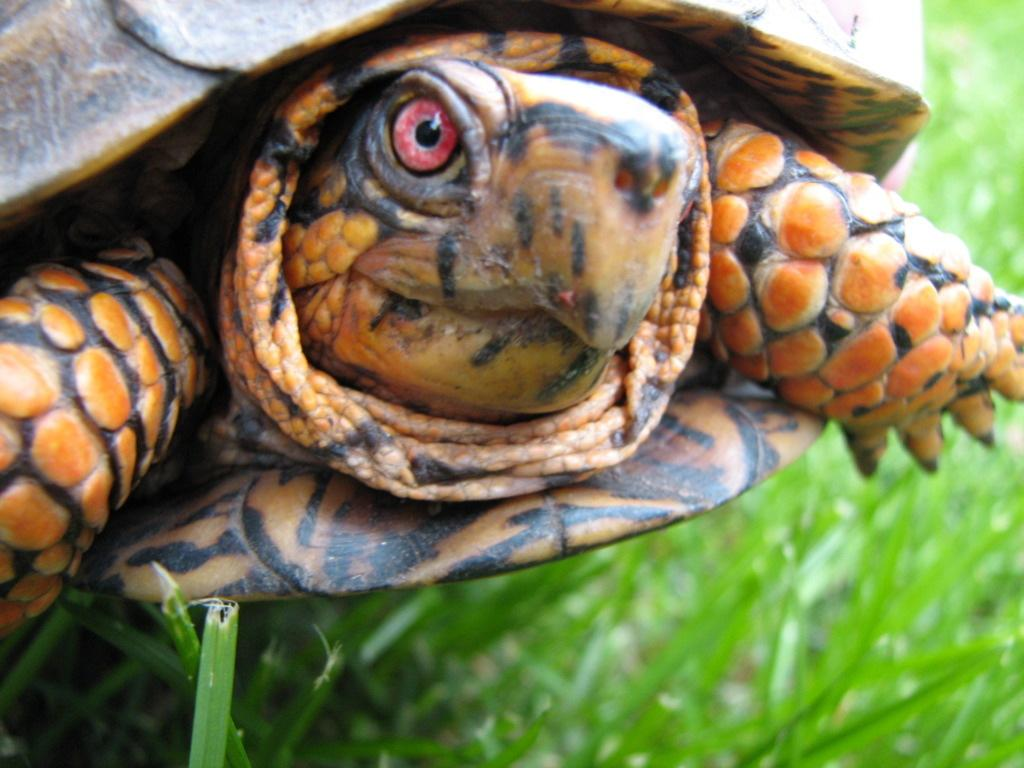What animal is present in the image? There is a tortoise in the image. Where is the tortoise located? The tortoise is on the grass. What type of bomb can be seen in the image? There is no bomb present in the image; it features a tortoise on the grass. How many rings is the wren wearing in the image? There is no wren present in the image, so it is not possible to determine how many rings it might be wearing. 